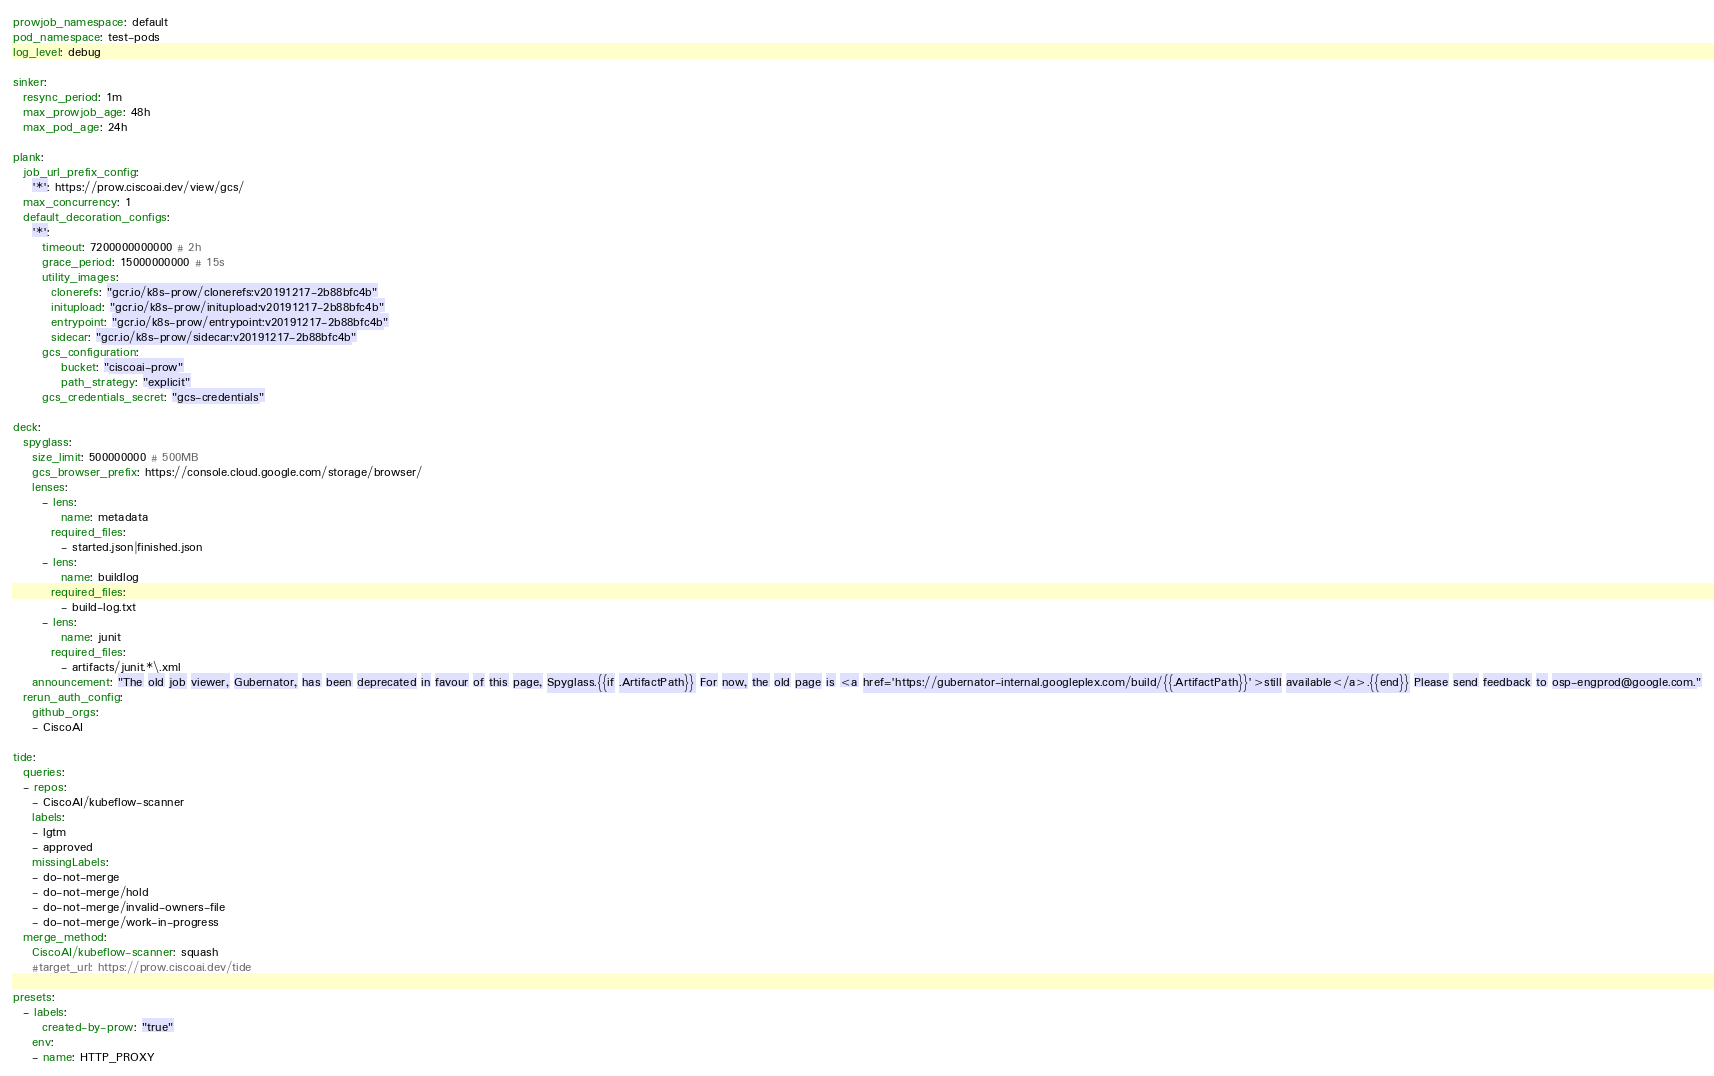Convert code to text. <code><loc_0><loc_0><loc_500><loc_500><_YAML_>prowjob_namespace: default
pod_namespace: test-pods
log_level: debug

sinker:
  resync_period: 1m
  max_prowjob_age: 48h
  max_pod_age: 24h

plank:
  job_url_prefix_config:
    '*': https://prow.ciscoai.dev/view/gcs/
  max_concurrency: 1
  default_decoration_configs:
    '*':
      timeout: 7200000000000 # 2h
      grace_period: 15000000000 # 15s
      utility_images:
        clonerefs: "gcr.io/k8s-prow/clonerefs:v20191217-2b88bfc4b"
        initupload: "gcr.io/k8s-prow/initupload:v20191217-2b88bfc4b"
        entrypoint: "gcr.io/k8s-prow/entrypoint:v20191217-2b88bfc4b"
        sidecar: "gcr.io/k8s-prow/sidecar:v20191217-2b88bfc4b"
      gcs_configuration:
          bucket: "ciscoai-prow"
          path_strategy: "explicit"
      gcs_credentials_secret: "gcs-credentials"

deck:
  spyglass:
    size_limit: 500000000 # 500MB
    gcs_browser_prefix: https://console.cloud.google.com/storage/browser/
    lenses:
      - lens:
          name: metadata
        required_files:
          - started.json|finished.json
      - lens:
          name: buildlog
        required_files:
          - build-log.txt
      - lens:
          name: junit
        required_files:
          - artifacts/junit.*\.xml
    announcement: "The old job viewer, Gubernator, has been deprecated in favour of this page, Spyglass.{{if .ArtifactPath}} For now, the old page is <a href='https://gubernator-internal.googleplex.com/build/{{.ArtifactPath}}'>still available</a>.{{end}} Please send feedback to osp-engprod@google.com."
  rerun_auth_config:
    github_orgs:
    - CiscoAI

tide:
  queries:
  - repos:
    - CiscoAI/kubeflow-scanner
    labels:
    - lgtm
    - approved
    missingLabels:
    - do-not-merge
    - do-not-merge/hold
    - do-not-merge/invalid-owners-file
    - do-not-merge/work-in-progress
  merge_method:
    CiscoAI/kubeflow-scanner: squash
    #target_url: https://prow.ciscoai.dev/tide

presets:
  - labels:
      created-by-prow: "true"
    env:
    - name: HTTP_PROXY</code> 